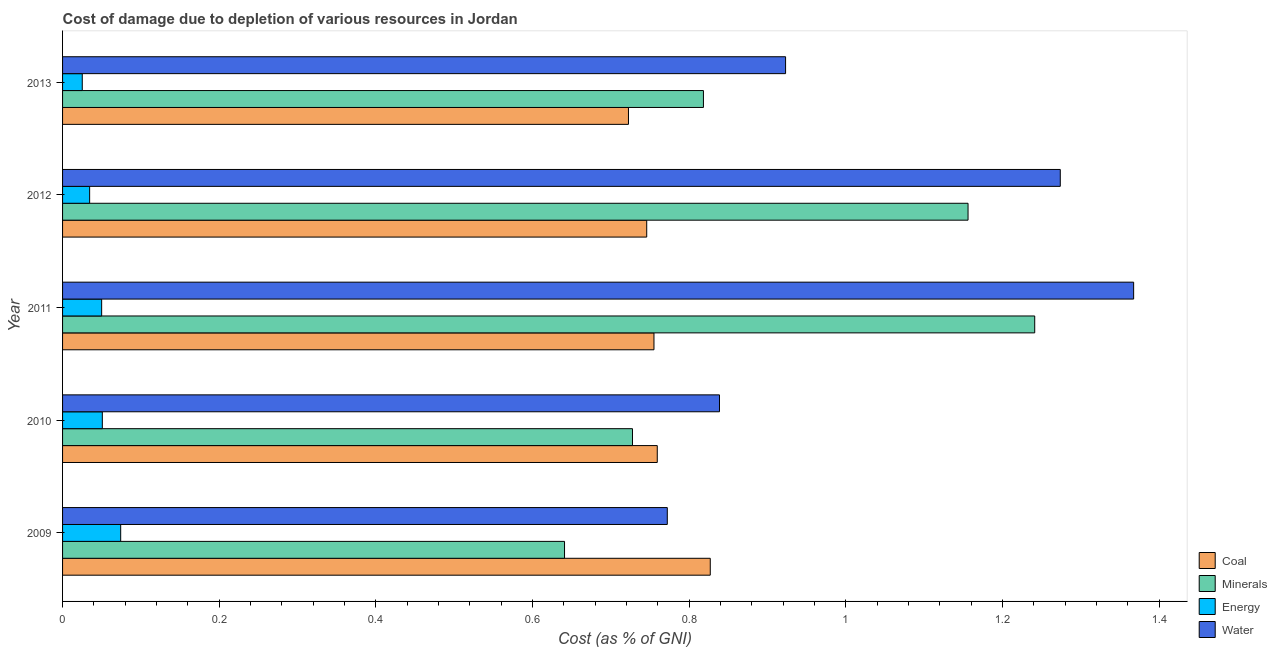How many bars are there on the 1st tick from the top?
Give a very brief answer. 4. How many bars are there on the 5th tick from the bottom?
Ensure brevity in your answer.  4. What is the label of the 3rd group of bars from the top?
Keep it short and to the point. 2011. What is the cost of damage due to depletion of coal in 2009?
Keep it short and to the point. 0.83. Across all years, what is the maximum cost of damage due to depletion of energy?
Give a very brief answer. 0.07. Across all years, what is the minimum cost of damage due to depletion of minerals?
Ensure brevity in your answer.  0.64. In which year was the cost of damage due to depletion of coal minimum?
Provide a short and direct response. 2013. What is the total cost of damage due to depletion of energy in the graph?
Your answer should be very brief. 0.23. What is the difference between the cost of damage due to depletion of coal in 2009 and that in 2013?
Make the answer very short. 0.1. What is the difference between the cost of damage due to depletion of minerals in 2010 and the cost of damage due to depletion of energy in 2013?
Offer a terse response. 0.7. What is the average cost of damage due to depletion of energy per year?
Your response must be concise. 0.05. In the year 2013, what is the difference between the cost of damage due to depletion of minerals and cost of damage due to depletion of coal?
Offer a very short reply. 0.1. In how many years, is the cost of damage due to depletion of minerals greater than 1.04 %?
Give a very brief answer. 2. What is the ratio of the cost of damage due to depletion of energy in 2009 to that in 2010?
Your response must be concise. 1.46. What is the difference between the highest and the second highest cost of damage due to depletion of minerals?
Your response must be concise. 0.09. In how many years, is the cost of damage due to depletion of coal greater than the average cost of damage due to depletion of coal taken over all years?
Your answer should be compact. 1. What does the 2nd bar from the top in 2009 represents?
Make the answer very short. Energy. What does the 4th bar from the bottom in 2012 represents?
Offer a very short reply. Water. How many bars are there?
Your answer should be compact. 20. Are all the bars in the graph horizontal?
Give a very brief answer. Yes. Does the graph contain grids?
Give a very brief answer. No. Where does the legend appear in the graph?
Provide a short and direct response. Bottom right. What is the title of the graph?
Your answer should be compact. Cost of damage due to depletion of various resources in Jordan . Does "Pre-primary schools" appear as one of the legend labels in the graph?
Keep it short and to the point. No. What is the label or title of the X-axis?
Your answer should be very brief. Cost (as % of GNI). What is the label or title of the Y-axis?
Provide a succinct answer. Year. What is the Cost (as % of GNI) of Coal in 2009?
Your response must be concise. 0.83. What is the Cost (as % of GNI) in Minerals in 2009?
Make the answer very short. 0.64. What is the Cost (as % of GNI) in Energy in 2009?
Your answer should be very brief. 0.07. What is the Cost (as % of GNI) of Water in 2009?
Make the answer very short. 0.77. What is the Cost (as % of GNI) in Coal in 2010?
Make the answer very short. 0.76. What is the Cost (as % of GNI) in Minerals in 2010?
Offer a very short reply. 0.73. What is the Cost (as % of GNI) of Energy in 2010?
Your answer should be compact. 0.05. What is the Cost (as % of GNI) in Water in 2010?
Offer a very short reply. 0.84. What is the Cost (as % of GNI) in Coal in 2011?
Your response must be concise. 0.76. What is the Cost (as % of GNI) of Minerals in 2011?
Give a very brief answer. 1.24. What is the Cost (as % of GNI) in Energy in 2011?
Your answer should be compact. 0.05. What is the Cost (as % of GNI) in Water in 2011?
Provide a short and direct response. 1.37. What is the Cost (as % of GNI) of Coal in 2012?
Your answer should be compact. 0.75. What is the Cost (as % of GNI) in Minerals in 2012?
Ensure brevity in your answer.  1.16. What is the Cost (as % of GNI) in Energy in 2012?
Your response must be concise. 0.03. What is the Cost (as % of GNI) of Water in 2012?
Offer a terse response. 1.27. What is the Cost (as % of GNI) of Coal in 2013?
Ensure brevity in your answer.  0.72. What is the Cost (as % of GNI) in Minerals in 2013?
Your response must be concise. 0.82. What is the Cost (as % of GNI) in Energy in 2013?
Your answer should be very brief. 0.03. What is the Cost (as % of GNI) of Water in 2013?
Your answer should be very brief. 0.92. Across all years, what is the maximum Cost (as % of GNI) in Coal?
Keep it short and to the point. 0.83. Across all years, what is the maximum Cost (as % of GNI) of Minerals?
Your response must be concise. 1.24. Across all years, what is the maximum Cost (as % of GNI) of Energy?
Offer a terse response. 0.07. Across all years, what is the maximum Cost (as % of GNI) in Water?
Offer a terse response. 1.37. Across all years, what is the minimum Cost (as % of GNI) of Coal?
Keep it short and to the point. 0.72. Across all years, what is the minimum Cost (as % of GNI) of Minerals?
Keep it short and to the point. 0.64. Across all years, what is the minimum Cost (as % of GNI) in Energy?
Ensure brevity in your answer.  0.03. Across all years, what is the minimum Cost (as % of GNI) of Water?
Make the answer very short. 0.77. What is the total Cost (as % of GNI) in Coal in the graph?
Ensure brevity in your answer.  3.81. What is the total Cost (as % of GNI) in Minerals in the graph?
Provide a short and direct response. 4.58. What is the total Cost (as % of GNI) of Energy in the graph?
Provide a succinct answer. 0.23. What is the total Cost (as % of GNI) in Water in the graph?
Offer a terse response. 5.17. What is the difference between the Cost (as % of GNI) in Coal in 2009 and that in 2010?
Your answer should be compact. 0.07. What is the difference between the Cost (as % of GNI) of Minerals in 2009 and that in 2010?
Keep it short and to the point. -0.09. What is the difference between the Cost (as % of GNI) in Energy in 2009 and that in 2010?
Make the answer very short. 0.02. What is the difference between the Cost (as % of GNI) of Water in 2009 and that in 2010?
Offer a terse response. -0.07. What is the difference between the Cost (as % of GNI) of Coal in 2009 and that in 2011?
Your answer should be compact. 0.07. What is the difference between the Cost (as % of GNI) of Minerals in 2009 and that in 2011?
Your answer should be very brief. -0.6. What is the difference between the Cost (as % of GNI) in Energy in 2009 and that in 2011?
Offer a very short reply. 0.02. What is the difference between the Cost (as % of GNI) in Water in 2009 and that in 2011?
Your answer should be very brief. -0.6. What is the difference between the Cost (as % of GNI) of Coal in 2009 and that in 2012?
Ensure brevity in your answer.  0.08. What is the difference between the Cost (as % of GNI) in Minerals in 2009 and that in 2012?
Give a very brief answer. -0.52. What is the difference between the Cost (as % of GNI) in Energy in 2009 and that in 2012?
Your answer should be compact. 0.04. What is the difference between the Cost (as % of GNI) of Water in 2009 and that in 2012?
Offer a terse response. -0.5. What is the difference between the Cost (as % of GNI) in Coal in 2009 and that in 2013?
Provide a short and direct response. 0.1. What is the difference between the Cost (as % of GNI) in Minerals in 2009 and that in 2013?
Offer a very short reply. -0.18. What is the difference between the Cost (as % of GNI) in Energy in 2009 and that in 2013?
Ensure brevity in your answer.  0.05. What is the difference between the Cost (as % of GNI) of Water in 2009 and that in 2013?
Your response must be concise. -0.15. What is the difference between the Cost (as % of GNI) of Coal in 2010 and that in 2011?
Give a very brief answer. 0. What is the difference between the Cost (as % of GNI) in Minerals in 2010 and that in 2011?
Your answer should be very brief. -0.51. What is the difference between the Cost (as % of GNI) in Energy in 2010 and that in 2011?
Your answer should be very brief. 0. What is the difference between the Cost (as % of GNI) of Water in 2010 and that in 2011?
Your answer should be compact. -0.53. What is the difference between the Cost (as % of GNI) in Coal in 2010 and that in 2012?
Provide a short and direct response. 0.01. What is the difference between the Cost (as % of GNI) of Minerals in 2010 and that in 2012?
Make the answer very short. -0.43. What is the difference between the Cost (as % of GNI) of Energy in 2010 and that in 2012?
Your answer should be compact. 0.02. What is the difference between the Cost (as % of GNI) of Water in 2010 and that in 2012?
Your answer should be very brief. -0.44. What is the difference between the Cost (as % of GNI) in Coal in 2010 and that in 2013?
Your answer should be compact. 0.04. What is the difference between the Cost (as % of GNI) in Minerals in 2010 and that in 2013?
Your answer should be compact. -0.09. What is the difference between the Cost (as % of GNI) in Energy in 2010 and that in 2013?
Offer a very short reply. 0.03. What is the difference between the Cost (as % of GNI) of Water in 2010 and that in 2013?
Provide a succinct answer. -0.08. What is the difference between the Cost (as % of GNI) of Coal in 2011 and that in 2012?
Provide a short and direct response. 0.01. What is the difference between the Cost (as % of GNI) in Minerals in 2011 and that in 2012?
Your answer should be compact. 0.09. What is the difference between the Cost (as % of GNI) of Energy in 2011 and that in 2012?
Provide a succinct answer. 0.02. What is the difference between the Cost (as % of GNI) of Water in 2011 and that in 2012?
Your answer should be very brief. 0.09. What is the difference between the Cost (as % of GNI) in Coal in 2011 and that in 2013?
Ensure brevity in your answer.  0.03. What is the difference between the Cost (as % of GNI) of Minerals in 2011 and that in 2013?
Make the answer very short. 0.42. What is the difference between the Cost (as % of GNI) in Energy in 2011 and that in 2013?
Your response must be concise. 0.02. What is the difference between the Cost (as % of GNI) of Water in 2011 and that in 2013?
Offer a terse response. 0.44. What is the difference between the Cost (as % of GNI) in Coal in 2012 and that in 2013?
Your answer should be very brief. 0.02. What is the difference between the Cost (as % of GNI) of Minerals in 2012 and that in 2013?
Offer a terse response. 0.34. What is the difference between the Cost (as % of GNI) in Energy in 2012 and that in 2013?
Ensure brevity in your answer.  0.01. What is the difference between the Cost (as % of GNI) in Water in 2012 and that in 2013?
Ensure brevity in your answer.  0.35. What is the difference between the Cost (as % of GNI) in Coal in 2009 and the Cost (as % of GNI) in Minerals in 2010?
Provide a short and direct response. 0.1. What is the difference between the Cost (as % of GNI) in Coal in 2009 and the Cost (as % of GNI) in Energy in 2010?
Give a very brief answer. 0.78. What is the difference between the Cost (as % of GNI) of Coal in 2009 and the Cost (as % of GNI) of Water in 2010?
Give a very brief answer. -0.01. What is the difference between the Cost (as % of GNI) in Minerals in 2009 and the Cost (as % of GNI) in Energy in 2010?
Your answer should be very brief. 0.59. What is the difference between the Cost (as % of GNI) in Minerals in 2009 and the Cost (as % of GNI) in Water in 2010?
Ensure brevity in your answer.  -0.2. What is the difference between the Cost (as % of GNI) in Energy in 2009 and the Cost (as % of GNI) in Water in 2010?
Make the answer very short. -0.76. What is the difference between the Cost (as % of GNI) of Coal in 2009 and the Cost (as % of GNI) of Minerals in 2011?
Ensure brevity in your answer.  -0.41. What is the difference between the Cost (as % of GNI) in Coal in 2009 and the Cost (as % of GNI) in Energy in 2011?
Offer a terse response. 0.78. What is the difference between the Cost (as % of GNI) of Coal in 2009 and the Cost (as % of GNI) of Water in 2011?
Your response must be concise. -0.54. What is the difference between the Cost (as % of GNI) in Minerals in 2009 and the Cost (as % of GNI) in Energy in 2011?
Provide a succinct answer. 0.59. What is the difference between the Cost (as % of GNI) in Minerals in 2009 and the Cost (as % of GNI) in Water in 2011?
Your response must be concise. -0.73. What is the difference between the Cost (as % of GNI) in Energy in 2009 and the Cost (as % of GNI) in Water in 2011?
Keep it short and to the point. -1.29. What is the difference between the Cost (as % of GNI) in Coal in 2009 and the Cost (as % of GNI) in Minerals in 2012?
Provide a succinct answer. -0.33. What is the difference between the Cost (as % of GNI) in Coal in 2009 and the Cost (as % of GNI) in Energy in 2012?
Give a very brief answer. 0.79. What is the difference between the Cost (as % of GNI) of Coal in 2009 and the Cost (as % of GNI) of Water in 2012?
Ensure brevity in your answer.  -0.45. What is the difference between the Cost (as % of GNI) of Minerals in 2009 and the Cost (as % of GNI) of Energy in 2012?
Your answer should be compact. 0.61. What is the difference between the Cost (as % of GNI) in Minerals in 2009 and the Cost (as % of GNI) in Water in 2012?
Offer a terse response. -0.63. What is the difference between the Cost (as % of GNI) in Energy in 2009 and the Cost (as % of GNI) in Water in 2012?
Your answer should be compact. -1.2. What is the difference between the Cost (as % of GNI) in Coal in 2009 and the Cost (as % of GNI) in Minerals in 2013?
Offer a terse response. 0.01. What is the difference between the Cost (as % of GNI) of Coal in 2009 and the Cost (as % of GNI) of Energy in 2013?
Give a very brief answer. 0.8. What is the difference between the Cost (as % of GNI) in Coal in 2009 and the Cost (as % of GNI) in Water in 2013?
Provide a short and direct response. -0.1. What is the difference between the Cost (as % of GNI) in Minerals in 2009 and the Cost (as % of GNI) in Energy in 2013?
Give a very brief answer. 0.62. What is the difference between the Cost (as % of GNI) in Minerals in 2009 and the Cost (as % of GNI) in Water in 2013?
Make the answer very short. -0.28. What is the difference between the Cost (as % of GNI) in Energy in 2009 and the Cost (as % of GNI) in Water in 2013?
Keep it short and to the point. -0.85. What is the difference between the Cost (as % of GNI) of Coal in 2010 and the Cost (as % of GNI) of Minerals in 2011?
Keep it short and to the point. -0.48. What is the difference between the Cost (as % of GNI) in Coal in 2010 and the Cost (as % of GNI) in Energy in 2011?
Your answer should be very brief. 0.71. What is the difference between the Cost (as % of GNI) in Coal in 2010 and the Cost (as % of GNI) in Water in 2011?
Your answer should be very brief. -0.61. What is the difference between the Cost (as % of GNI) of Minerals in 2010 and the Cost (as % of GNI) of Energy in 2011?
Your answer should be compact. 0.68. What is the difference between the Cost (as % of GNI) in Minerals in 2010 and the Cost (as % of GNI) in Water in 2011?
Your answer should be compact. -0.64. What is the difference between the Cost (as % of GNI) of Energy in 2010 and the Cost (as % of GNI) of Water in 2011?
Offer a very short reply. -1.32. What is the difference between the Cost (as % of GNI) in Coal in 2010 and the Cost (as % of GNI) in Minerals in 2012?
Give a very brief answer. -0.4. What is the difference between the Cost (as % of GNI) of Coal in 2010 and the Cost (as % of GNI) of Energy in 2012?
Your response must be concise. 0.72. What is the difference between the Cost (as % of GNI) in Coal in 2010 and the Cost (as % of GNI) in Water in 2012?
Provide a succinct answer. -0.51. What is the difference between the Cost (as % of GNI) of Minerals in 2010 and the Cost (as % of GNI) of Energy in 2012?
Your response must be concise. 0.69. What is the difference between the Cost (as % of GNI) of Minerals in 2010 and the Cost (as % of GNI) of Water in 2012?
Provide a succinct answer. -0.55. What is the difference between the Cost (as % of GNI) in Energy in 2010 and the Cost (as % of GNI) in Water in 2012?
Make the answer very short. -1.22. What is the difference between the Cost (as % of GNI) in Coal in 2010 and the Cost (as % of GNI) in Minerals in 2013?
Give a very brief answer. -0.06. What is the difference between the Cost (as % of GNI) in Coal in 2010 and the Cost (as % of GNI) in Energy in 2013?
Offer a very short reply. 0.73. What is the difference between the Cost (as % of GNI) in Coal in 2010 and the Cost (as % of GNI) in Water in 2013?
Your answer should be very brief. -0.16. What is the difference between the Cost (as % of GNI) of Minerals in 2010 and the Cost (as % of GNI) of Energy in 2013?
Make the answer very short. 0.7. What is the difference between the Cost (as % of GNI) of Minerals in 2010 and the Cost (as % of GNI) of Water in 2013?
Offer a very short reply. -0.2. What is the difference between the Cost (as % of GNI) in Energy in 2010 and the Cost (as % of GNI) in Water in 2013?
Keep it short and to the point. -0.87. What is the difference between the Cost (as % of GNI) in Coal in 2011 and the Cost (as % of GNI) in Minerals in 2012?
Provide a short and direct response. -0.4. What is the difference between the Cost (as % of GNI) in Coal in 2011 and the Cost (as % of GNI) in Energy in 2012?
Provide a succinct answer. 0.72. What is the difference between the Cost (as % of GNI) of Coal in 2011 and the Cost (as % of GNI) of Water in 2012?
Keep it short and to the point. -0.52. What is the difference between the Cost (as % of GNI) in Minerals in 2011 and the Cost (as % of GNI) in Energy in 2012?
Your response must be concise. 1.21. What is the difference between the Cost (as % of GNI) in Minerals in 2011 and the Cost (as % of GNI) in Water in 2012?
Your answer should be compact. -0.03. What is the difference between the Cost (as % of GNI) of Energy in 2011 and the Cost (as % of GNI) of Water in 2012?
Provide a succinct answer. -1.22. What is the difference between the Cost (as % of GNI) of Coal in 2011 and the Cost (as % of GNI) of Minerals in 2013?
Offer a very short reply. -0.06. What is the difference between the Cost (as % of GNI) of Coal in 2011 and the Cost (as % of GNI) of Energy in 2013?
Your answer should be very brief. 0.73. What is the difference between the Cost (as % of GNI) of Coal in 2011 and the Cost (as % of GNI) of Water in 2013?
Keep it short and to the point. -0.17. What is the difference between the Cost (as % of GNI) in Minerals in 2011 and the Cost (as % of GNI) in Energy in 2013?
Give a very brief answer. 1.22. What is the difference between the Cost (as % of GNI) of Minerals in 2011 and the Cost (as % of GNI) of Water in 2013?
Your response must be concise. 0.32. What is the difference between the Cost (as % of GNI) of Energy in 2011 and the Cost (as % of GNI) of Water in 2013?
Ensure brevity in your answer.  -0.87. What is the difference between the Cost (as % of GNI) in Coal in 2012 and the Cost (as % of GNI) in Minerals in 2013?
Your answer should be very brief. -0.07. What is the difference between the Cost (as % of GNI) in Coal in 2012 and the Cost (as % of GNI) in Energy in 2013?
Your answer should be compact. 0.72. What is the difference between the Cost (as % of GNI) in Coal in 2012 and the Cost (as % of GNI) in Water in 2013?
Give a very brief answer. -0.18. What is the difference between the Cost (as % of GNI) in Minerals in 2012 and the Cost (as % of GNI) in Energy in 2013?
Give a very brief answer. 1.13. What is the difference between the Cost (as % of GNI) of Minerals in 2012 and the Cost (as % of GNI) of Water in 2013?
Provide a succinct answer. 0.23. What is the difference between the Cost (as % of GNI) of Energy in 2012 and the Cost (as % of GNI) of Water in 2013?
Give a very brief answer. -0.89. What is the average Cost (as % of GNI) in Coal per year?
Your answer should be compact. 0.76. What is the average Cost (as % of GNI) in Minerals per year?
Offer a very short reply. 0.92. What is the average Cost (as % of GNI) of Energy per year?
Make the answer very short. 0.05. What is the average Cost (as % of GNI) in Water per year?
Provide a short and direct response. 1.03. In the year 2009, what is the difference between the Cost (as % of GNI) of Coal and Cost (as % of GNI) of Minerals?
Keep it short and to the point. 0.19. In the year 2009, what is the difference between the Cost (as % of GNI) of Coal and Cost (as % of GNI) of Energy?
Provide a short and direct response. 0.75. In the year 2009, what is the difference between the Cost (as % of GNI) in Coal and Cost (as % of GNI) in Water?
Your answer should be very brief. 0.05. In the year 2009, what is the difference between the Cost (as % of GNI) in Minerals and Cost (as % of GNI) in Energy?
Provide a succinct answer. 0.57. In the year 2009, what is the difference between the Cost (as % of GNI) in Minerals and Cost (as % of GNI) in Water?
Your response must be concise. -0.13. In the year 2009, what is the difference between the Cost (as % of GNI) in Energy and Cost (as % of GNI) in Water?
Make the answer very short. -0.7. In the year 2010, what is the difference between the Cost (as % of GNI) of Coal and Cost (as % of GNI) of Minerals?
Keep it short and to the point. 0.03. In the year 2010, what is the difference between the Cost (as % of GNI) in Coal and Cost (as % of GNI) in Energy?
Offer a very short reply. 0.71. In the year 2010, what is the difference between the Cost (as % of GNI) of Coal and Cost (as % of GNI) of Water?
Ensure brevity in your answer.  -0.08. In the year 2010, what is the difference between the Cost (as % of GNI) in Minerals and Cost (as % of GNI) in Energy?
Your response must be concise. 0.68. In the year 2010, what is the difference between the Cost (as % of GNI) of Minerals and Cost (as % of GNI) of Water?
Keep it short and to the point. -0.11. In the year 2010, what is the difference between the Cost (as % of GNI) in Energy and Cost (as % of GNI) in Water?
Provide a short and direct response. -0.79. In the year 2011, what is the difference between the Cost (as % of GNI) of Coal and Cost (as % of GNI) of Minerals?
Your answer should be compact. -0.49. In the year 2011, what is the difference between the Cost (as % of GNI) in Coal and Cost (as % of GNI) in Energy?
Ensure brevity in your answer.  0.71. In the year 2011, what is the difference between the Cost (as % of GNI) in Coal and Cost (as % of GNI) in Water?
Provide a short and direct response. -0.61. In the year 2011, what is the difference between the Cost (as % of GNI) of Minerals and Cost (as % of GNI) of Energy?
Offer a terse response. 1.19. In the year 2011, what is the difference between the Cost (as % of GNI) in Minerals and Cost (as % of GNI) in Water?
Offer a very short reply. -0.13. In the year 2011, what is the difference between the Cost (as % of GNI) in Energy and Cost (as % of GNI) in Water?
Your answer should be very brief. -1.32. In the year 2012, what is the difference between the Cost (as % of GNI) of Coal and Cost (as % of GNI) of Minerals?
Keep it short and to the point. -0.41. In the year 2012, what is the difference between the Cost (as % of GNI) of Coal and Cost (as % of GNI) of Energy?
Your response must be concise. 0.71. In the year 2012, what is the difference between the Cost (as % of GNI) in Coal and Cost (as % of GNI) in Water?
Offer a terse response. -0.53. In the year 2012, what is the difference between the Cost (as % of GNI) in Minerals and Cost (as % of GNI) in Energy?
Your answer should be very brief. 1.12. In the year 2012, what is the difference between the Cost (as % of GNI) in Minerals and Cost (as % of GNI) in Water?
Keep it short and to the point. -0.12. In the year 2012, what is the difference between the Cost (as % of GNI) of Energy and Cost (as % of GNI) of Water?
Your answer should be very brief. -1.24. In the year 2013, what is the difference between the Cost (as % of GNI) in Coal and Cost (as % of GNI) in Minerals?
Your answer should be very brief. -0.1. In the year 2013, what is the difference between the Cost (as % of GNI) of Coal and Cost (as % of GNI) of Energy?
Your response must be concise. 0.7. In the year 2013, what is the difference between the Cost (as % of GNI) in Coal and Cost (as % of GNI) in Water?
Your answer should be compact. -0.2. In the year 2013, what is the difference between the Cost (as % of GNI) in Minerals and Cost (as % of GNI) in Energy?
Your answer should be compact. 0.79. In the year 2013, what is the difference between the Cost (as % of GNI) in Minerals and Cost (as % of GNI) in Water?
Provide a succinct answer. -0.1. In the year 2013, what is the difference between the Cost (as % of GNI) in Energy and Cost (as % of GNI) in Water?
Give a very brief answer. -0.9. What is the ratio of the Cost (as % of GNI) in Coal in 2009 to that in 2010?
Offer a terse response. 1.09. What is the ratio of the Cost (as % of GNI) of Minerals in 2009 to that in 2010?
Keep it short and to the point. 0.88. What is the ratio of the Cost (as % of GNI) of Energy in 2009 to that in 2010?
Give a very brief answer. 1.46. What is the ratio of the Cost (as % of GNI) in Water in 2009 to that in 2010?
Keep it short and to the point. 0.92. What is the ratio of the Cost (as % of GNI) in Coal in 2009 to that in 2011?
Give a very brief answer. 1.1. What is the ratio of the Cost (as % of GNI) in Minerals in 2009 to that in 2011?
Offer a terse response. 0.52. What is the ratio of the Cost (as % of GNI) in Energy in 2009 to that in 2011?
Your response must be concise. 1.49. What is the ratio of the Cost (as % of GNI) in Water in 2009 to that in 2011?
Provide a succinct answer. 0.56. What is the ratio of the Cost (as % of GNI) of Coal in 2009 to that in 2012?
Give a very brief answer. 1.11. What is the ratio of the Cost (as % of GNI) of Minerals in 2009 to that in 2012?
Offer a very short reply. 0.55. What is the ratio of the Cost (as % of GNI) of Energy in 2009 to that in 2012?
Your answer should be compact. 2.15. What is the ratio of the Cost (as % of GNI) of Water in 2009 to that in 2012?
Your response must be concise. 0.61. What is the ratio of the Cost (as % of GNI) in Coal in 2009 to that in 2013?
Your answer should be compact. 1.14. What is the ratio of the Cost (as % of GNI) in Minerals in 2009 to that in 2013?
Your answer should be very brief. 0.78. What is the ratio of the Cost (as % of GNI) in Energy in 2009 to that in 2013?
Provide a short and direct response. 2.95. What is the ratio of the Cost (as % of GNI) in Water in 2009 to that in 2013?
Make the answer very short. 0.84. What is the ratio of the Cost (as % of GNI) in Coal in 2010 to that in 2011?
Ensure brevity in your answer.  1.01. What is the ratio of the Cost (as % of GNI) in Minerals in 2010 to that in 2011?
Keep it short and to the point. 0.59. What is the ratio of the Cost (as % of GNI) of Water in 2010 to that in 2011?
Ensure brevity in your answer.  0.61. What is the ratio of the Cost (as % of GNI) in Coal in 2010 to that in 2012?
Offer a terse response. 1.02. What is the ratio of the Cost (as % of GNI) in Minerals in 2010 to that in 2012?
Offer a very short reply. 0.63. What is the ratio of the Cost (as % of GNI) of Energy in 2010 to that in 2012?
Keep it short and to the point. 1.47. What is the ratio of the Cost (as % of GNI) in Water in 2010 to that in 2012?
Ensure brevity in your answer.  0.66. What is the ratio of the Cost (as % of GNI) of Coal in 2010 to that in 2013?
Offer a terse response. 1.05. What is the ratio of the Cost (as % of GNI) in Minerals in 2010 to that in 2013?
Your answer should be very brief. 0.89. What is the ratio of the Cost (as % of GNI) of Energy in 2010 to that in 2013?
Provide a succinct answer. 2.02. What is the ratio of the Cost (as % of GNI) of Water in 2010 to that in 2013?
Ensure brevity in your answer.  0.91. What is the ratio of the Cost (as % of GNI) of Coal in 2011 to that in 2012?
Provide a short and direct response. 1.01. What is the ratio of the Cost (as % of GNI) of Minerals in 2011 to that in 2012?
Your answer should be compact. 1.07. What is the ratio of the Cost (as % of GNI) in Energy in 2011 to that in 2012?
Keep it short and to the point. 1.44. What is the ratio of the Cost (as % of GNI) of Water in 2011 to that in 2012?
Make the answer very short. 1.07. What is the ratio of the Cost (as % of GNI) in Coal in 2011 to that in 2013?
Ensure brevity in your answer.  1.05. What is the ratio of the Cost (as % of GNI) of Minerals in 2011 to that in 2013?
Provide a succinct answer. 1.52. What is the ratio of the Cost (as % of GNI) of Energy in 2011 to that in 2013?
Provide a succinct answer. 1.98. What is the ratio of the Cost (as % of GNI) of Water in 2011 to that in 2013?
Ensure brevity in your answer.  1.48. What is the ratio of the Cost (as % of GNI) of Coal in 2012 to that in 2013?
Offer a very short reply. 1.03. What is the ratio of the Cost (as % of GNI) of Minerals in 2012 to that in 2013?
Your answer should be very brief. 1.41. What is the ratio of the Cost (as % of GNI) of Energy in 2012 to that in 2013?
Offer a very short reply. 1.37. What is the ratio of the Cost (as % of GNI) of Water in 2012 to that in 2013?
Your answer should be compact. 1.38. What is the difference between the highest and the second highest Cost (as % of GNI) in Coal?
Give a very brief answer. 0.07. What is the difference between the highest and the second highest Cost (as % of GNI) in Minerals?
Ensure brevity in your answer.  0.09. What is the difference between the highest and the second highest Cost (as % of GNI) in Energy?
Your answer should be very brief. 0.02. What is the difference between the highest and the second highest Cost (as % of GNI) of Water?
Give a very brief answer. 0.09. What is the difference between the highest and the lowest Cost (as % of GNI) in Coal?
Provide a short and direct response. 0.1. What is the difference between the highest and the lowest Cost (as % of GNI) in Minerals?
Make the answer very short. 0.6. What is the difference between the highest and the lowest Cost (as % of GNI) of Energy?
Make the answer very short. 0.05. What is the difference between the highest and the lowest Cost (as % of GNI) of Water?
Offer a terse response. 0.6. 